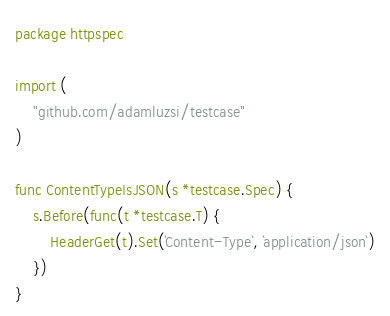Convert code to text. <code><loc_0><loc_0><loc_500><loc_500><_Go_>package httpspec

import (
	"github.com/adamluzsi/testcase"
)

func ContentTypeIsJSON(s *testcase.Spec) {
	s.Before(func(t *testcase.T) {
		HeaderGet(t).Set(`Content-Type`, `application/json`)
	})
}
</code> 